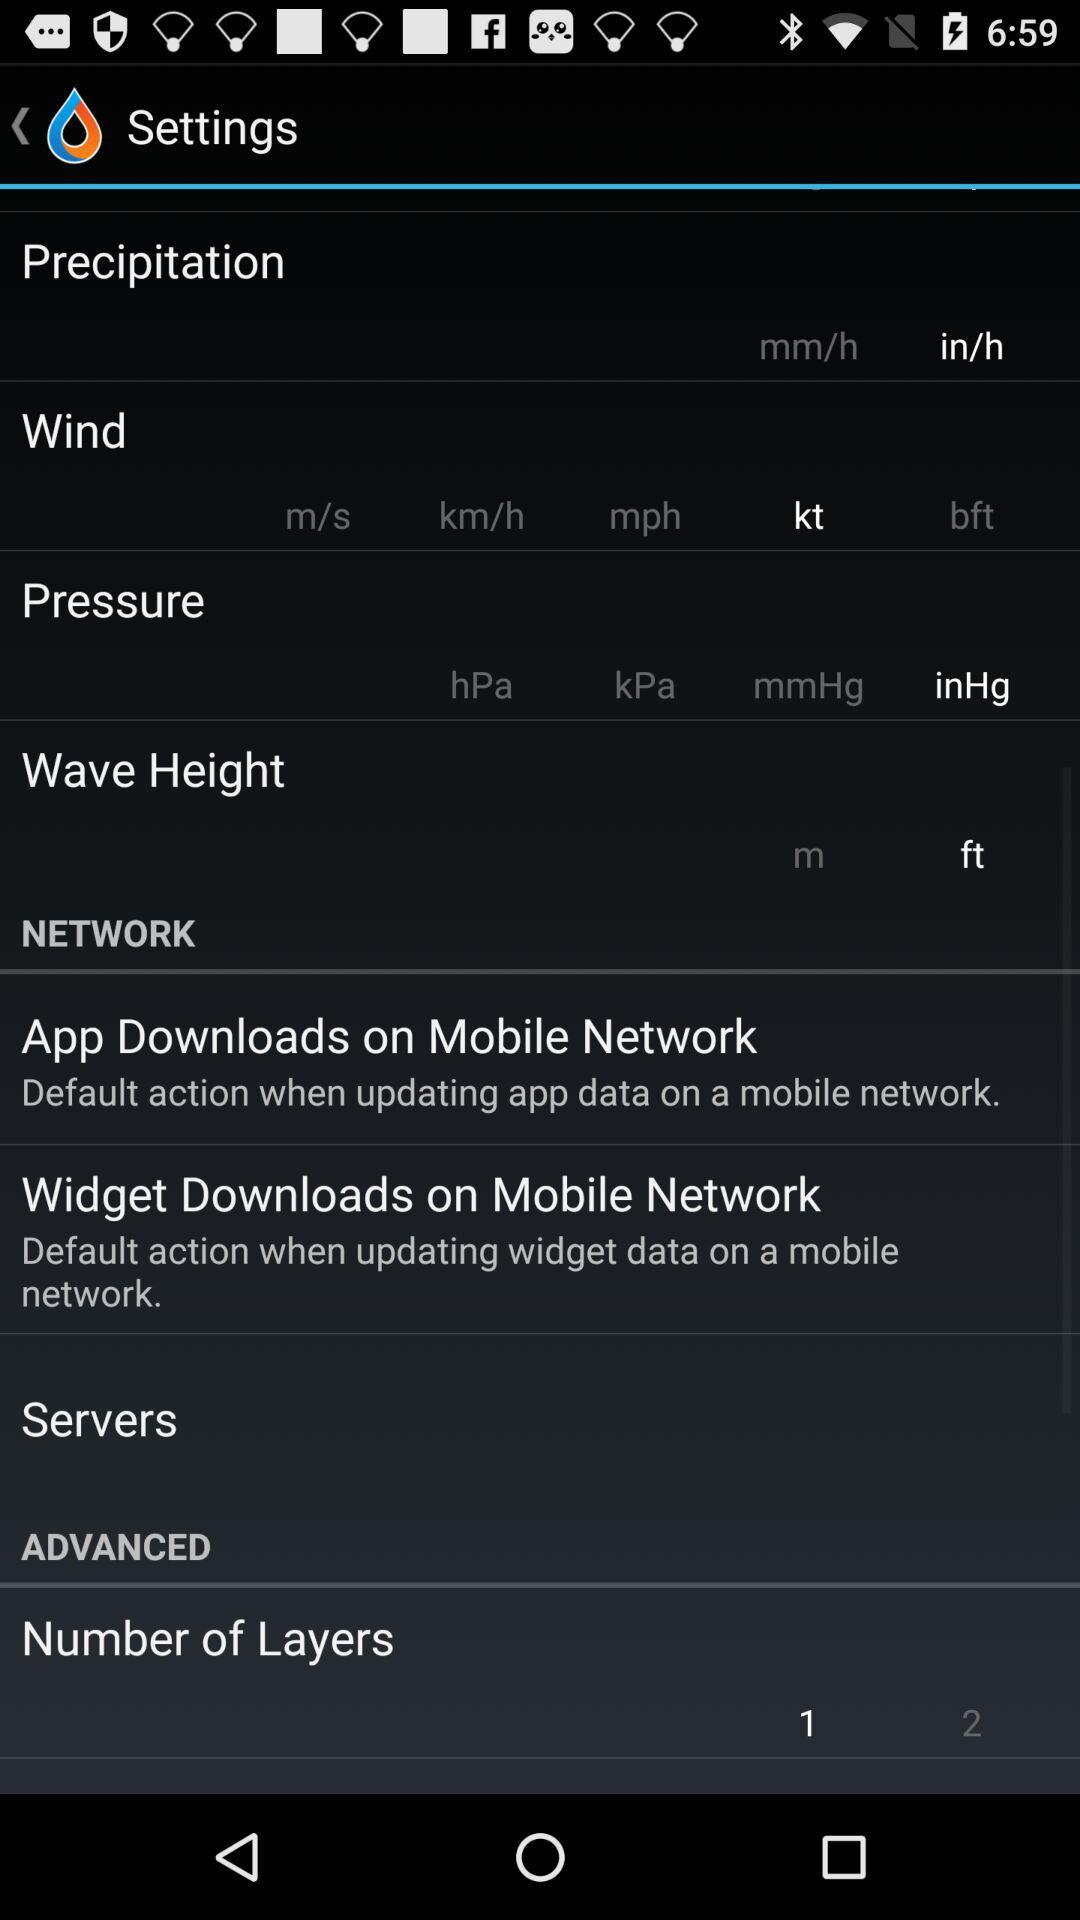What is the selected pressure unit? The selected pressure unit is inHg. 